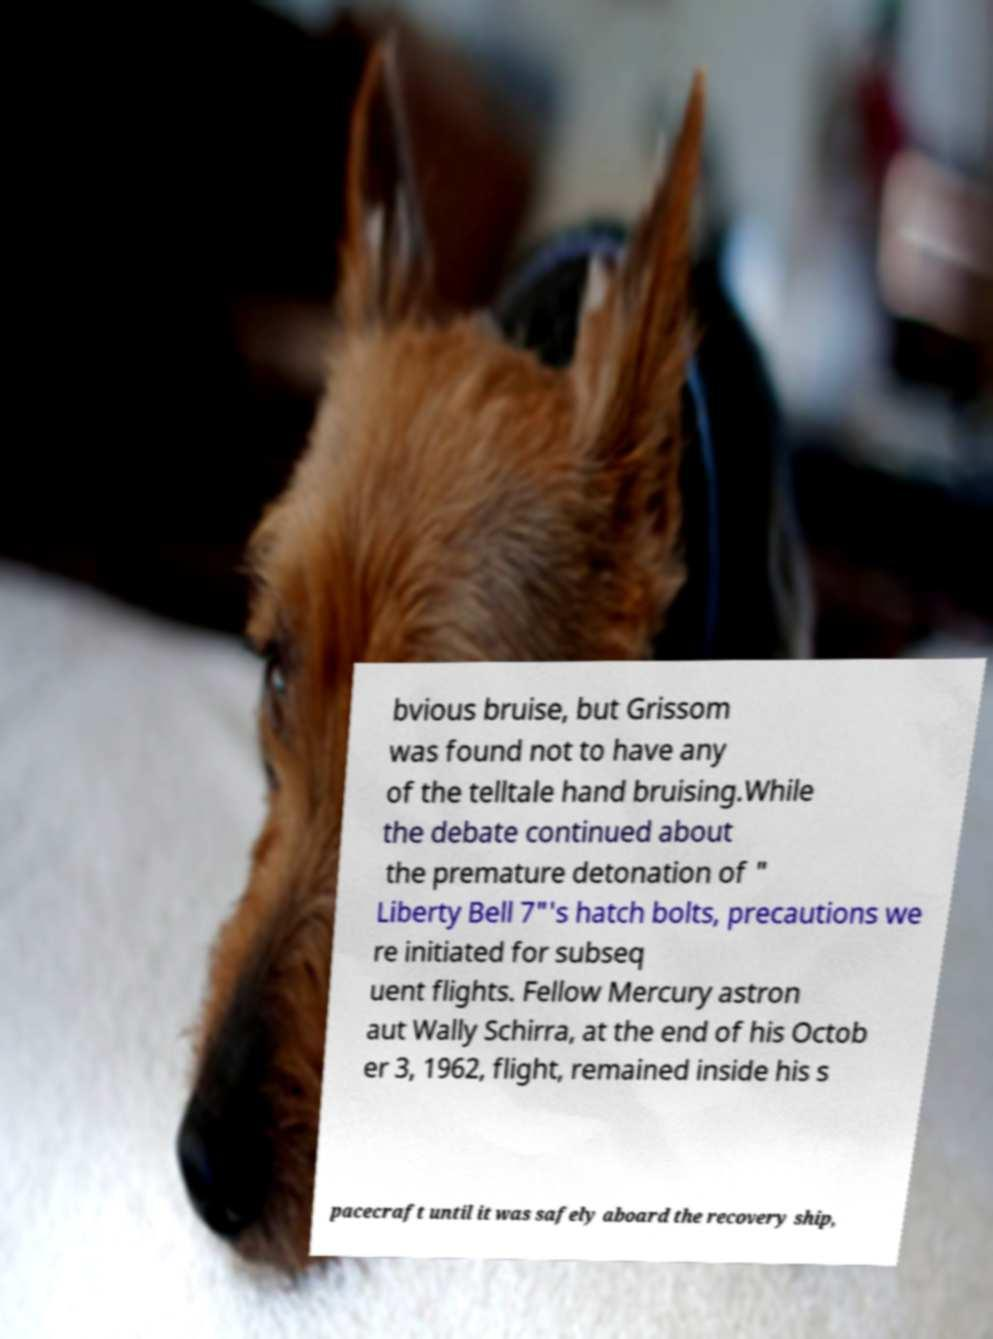There's text embedded in this image that I need extracted. Can you transcribe it verbatim? bvious bruise, but Grissom was found not to have any of the telltale hand bruising.While the debate continued about the premature detonation of " Liberty Bell 7"'s hatch bolts, precautions we re initiated for subseq uent flights. Fellow Mercury astron aut Wally Schirra, at the end of his Octob er 3, 1962, flight, remained inside his s pacecraft until it was safely aboard the recovery ship, 